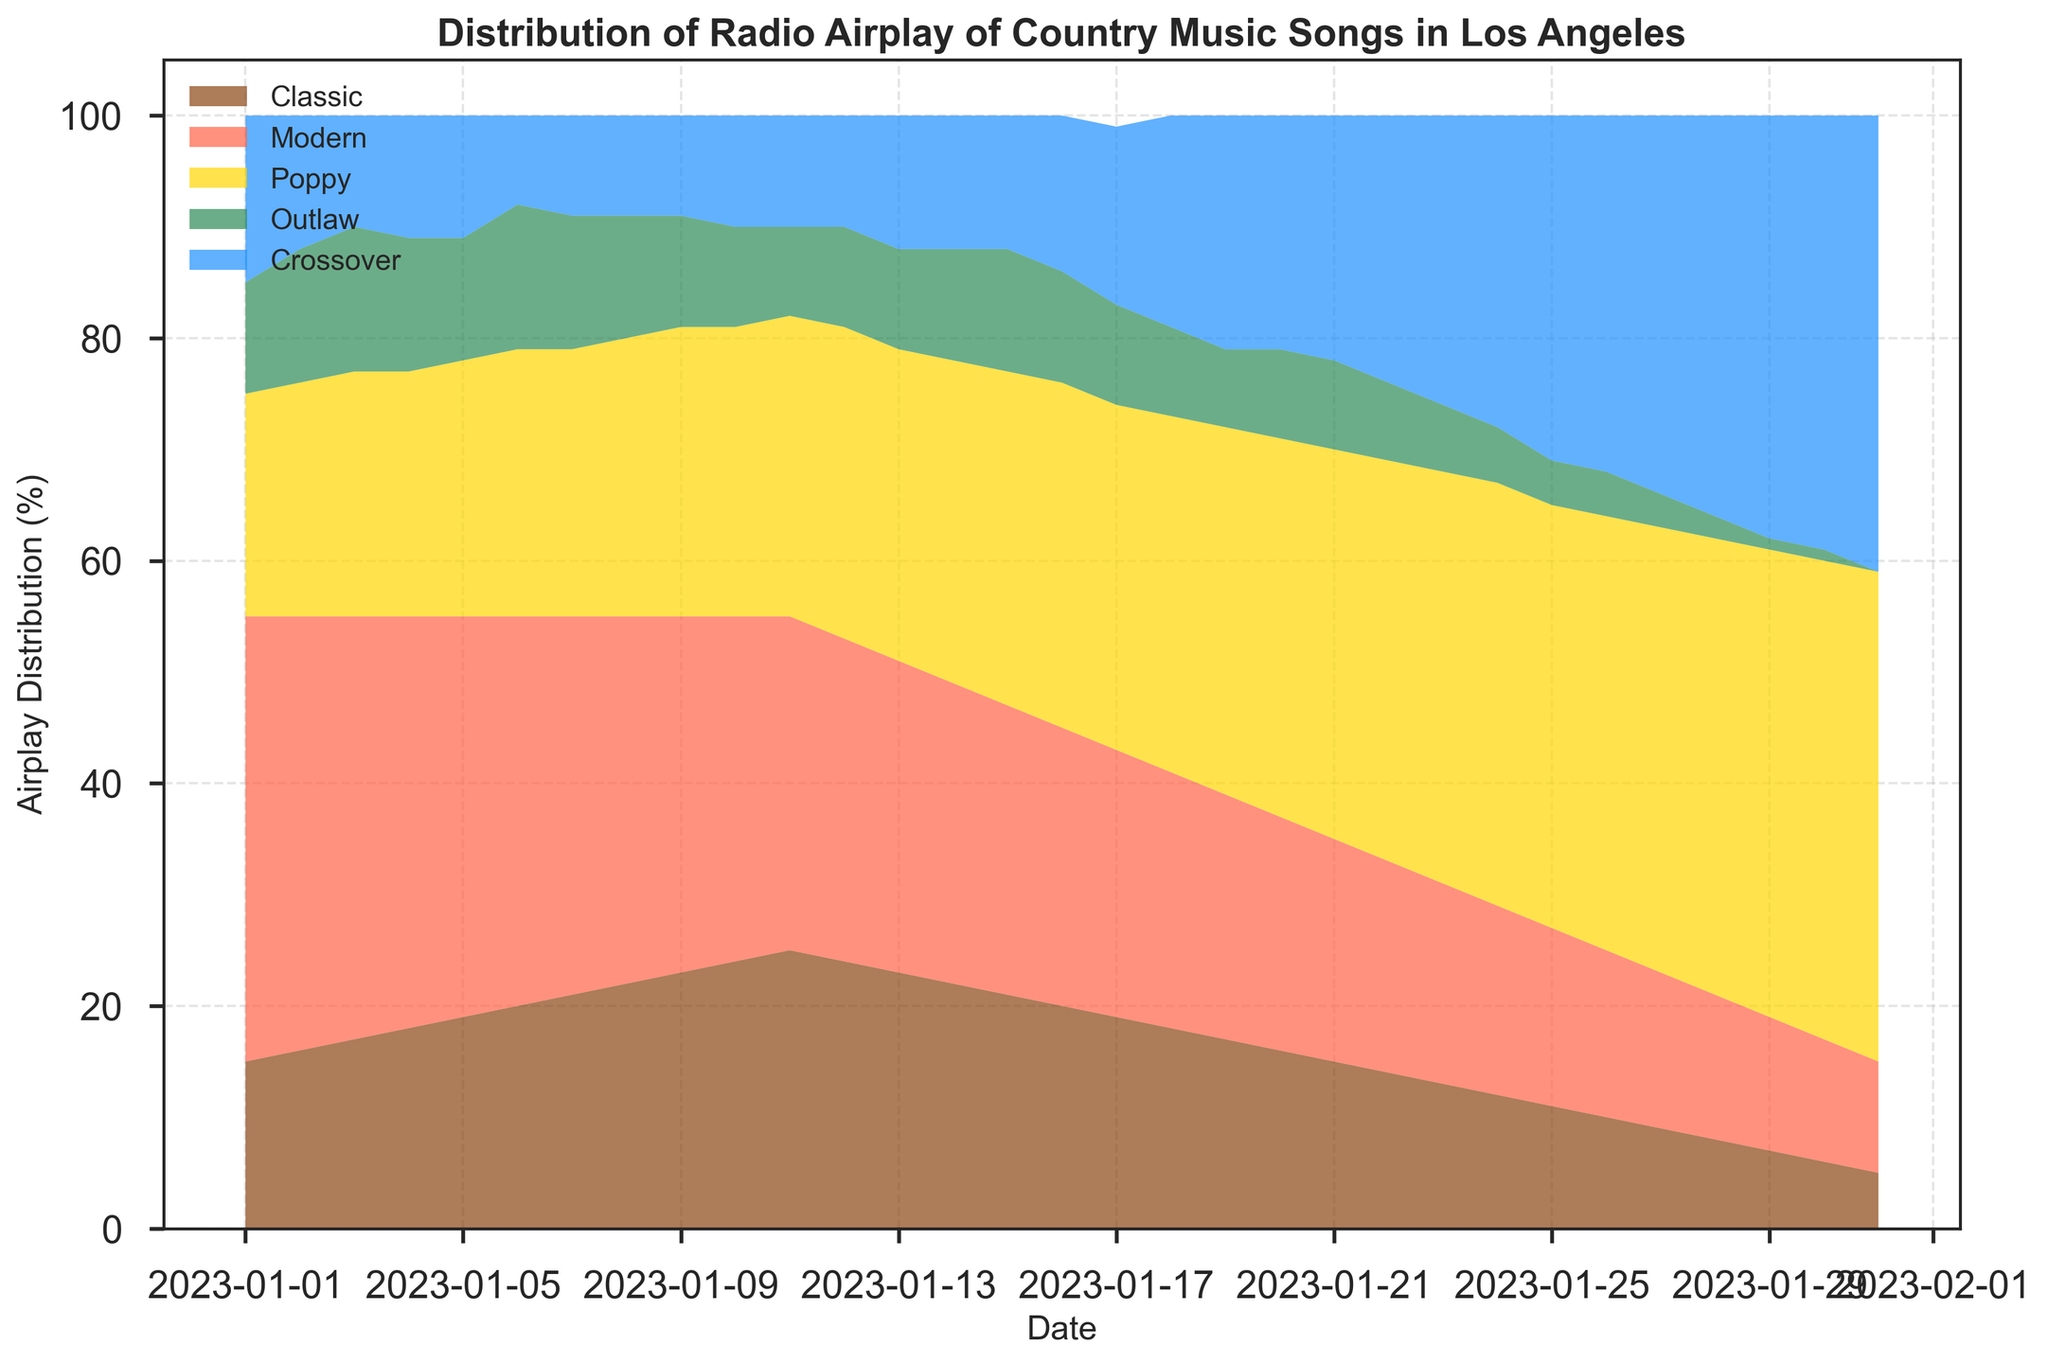What's the most played sub-genre on January 1, 2023? On January 1, 2023, the sub-genre with the highest value is 40, which corresponds to Modern on the area chart.
Answer: Modern Which sub-genre saw the greatest decrease in airplay from January 1 to January 31? By observing the area chart, the Modern sub-genre's airplay decreased from 40 to 10, resulting in a decrease of 30, which appears to be the largest drop among all sub-genres.
Answer: Modern On which date did the Poppy sub-genre surpass the Classic sub-genre? The first data point where the Poppy sub-genre's value (22) surpassed the Classic sub-genre's value (18) is on January 4, 2023, as seen in the area chart.
Answer: January 4, 2023 What is the combined airplay percentage of Modern and Crossover sub-genres on January 20, 2023? Summing the values for Modern (21) and Crossover (21) on January 20, the combined airplay percentage is 42.
Answer: 42 How did the airplay distribution for Outlaw change throughout January? The Outlaw sub-genre started at 10 on January 1, increased slightly to 13 on January 6, and then gradually decreased to 0 by January 31, as shown in the area chart.
Answer: Increased then decreased Compare the airplay distribution of the Classic and Crossover sub-genres on January 25, 2023. On January 25, the Classic sub-genre's airplay was 11%, while the Crossover sub-genre's airplay was 31%, indicating the Crossover was significantly more played on this date.
Answer: Crossover more played Which sub-genre consistently increased its airplay percentage over January? Examining the area chart, the Poppy sub-genre's airplay percentage consistently rose from 20 on January 1 to 44 on January 31.
Answer: Poppy What is the trend for the Modern sub-genre throughout January? The Modern sub-genre starts at 40 on January 1 and shows a consistent decline, ending at 10 by January 31 on the area chart.
Answer: Decreasing When did the Crossover sub-genre reach its peak airplay? The peak airplay for the Crossover sub-genre occurred on January 31 with a percentage of 41, as reflected in the area chart.
Answer: January 31 